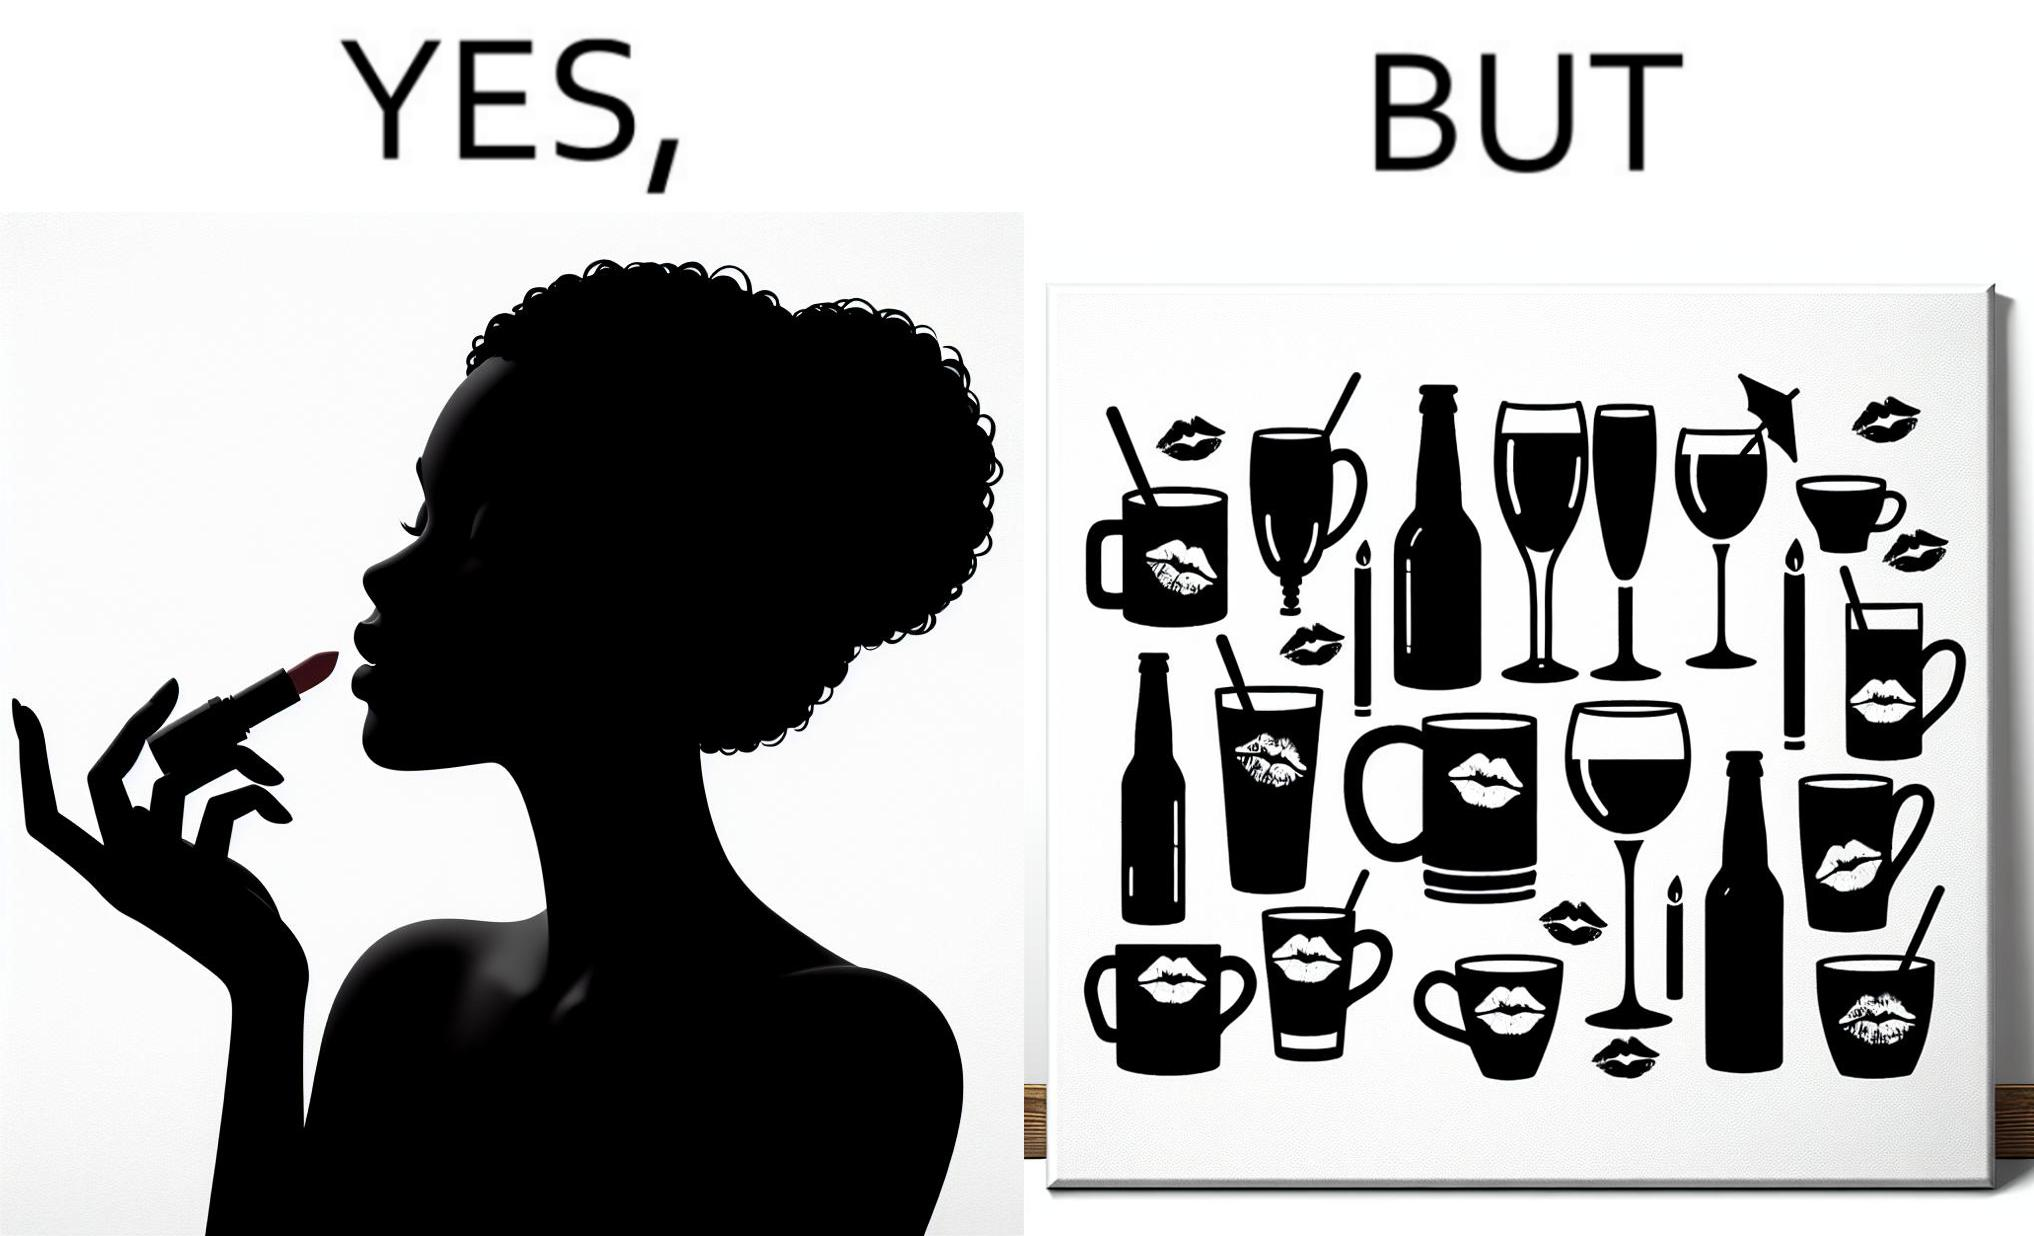What is the satirical meaning behind this image? The image is ironic, because the left image suggest that a person applies lipsticks on their lips to make their lips look attractive or to keep them hydrated but on the contrary it gets sticked to the glasses or mugs and gets wasted 